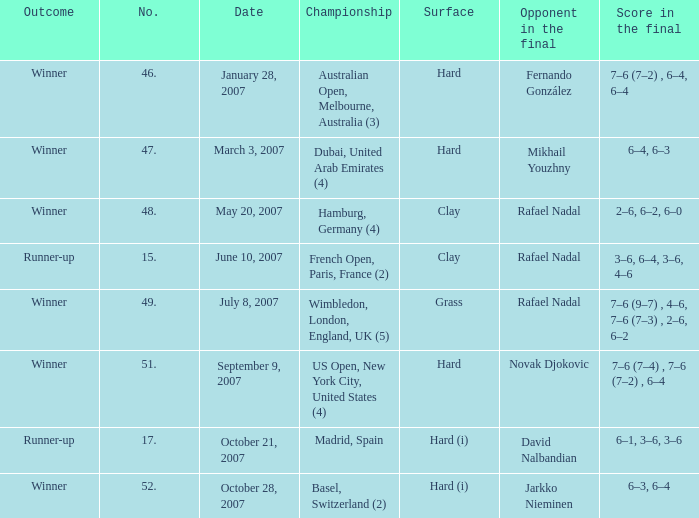Where does the competition take place with a final score of 6–1, 3–6, 3–6? Madrid, Spain. 